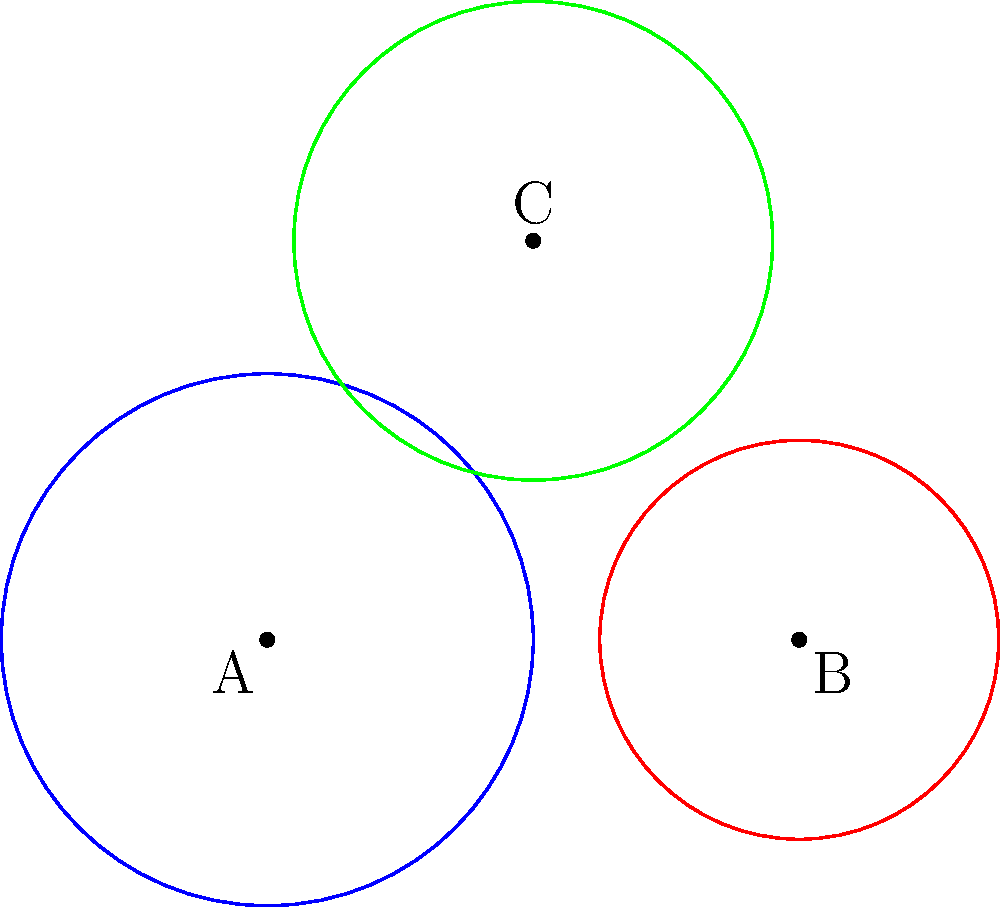In a Venn diagram representing user demographics on your social media platform, three circles A, B, and C represent different user groups. Circle A has a radius of 2 units, B has a radius of 1.5 units, and C has a radius of 1.8 units. If the centers of circles A and B are 4 units apart on a horizontal line, and the center of circle C is 3 units directly above the midpoint of AB, calculate the total area of the region where all three circles intersect. To solve this problem, we need to follow these steps:

1) First, we need to find the coordinates of the centers of the circles:
   A: (0, 0)
   B: (4, 0)
   C: (2, 3)

2) Next, we need to calculate the distances between the centers:
   AB = 4
   AC = $\sqrt{2^2 + 3^2} = \sqrt{13}$
   BC = $\sqrt{2^2 + 3^2} = \sqrt{13}$

3) Now, we need to check if the circles intersect at all. For this, the sum of any two radii should be greater than the distance between their centers:
   A + B: 2 + 1.5 = 3.5 < 4
   A + C: 2 + 1.8 = 3.8 > $\sqrt{13}$
   B + C: 1.5 + 1.8 = 3.3 > $\sqrt{13}$

   We can see that A and B don't intersect, but A and C, and B and C do intersect.

4) Since A and B don't intersect, there is no region where all three circles overlap.

5) Therefore, the area of the region where all three circles intersect is 0.
Answer: 0 square units 